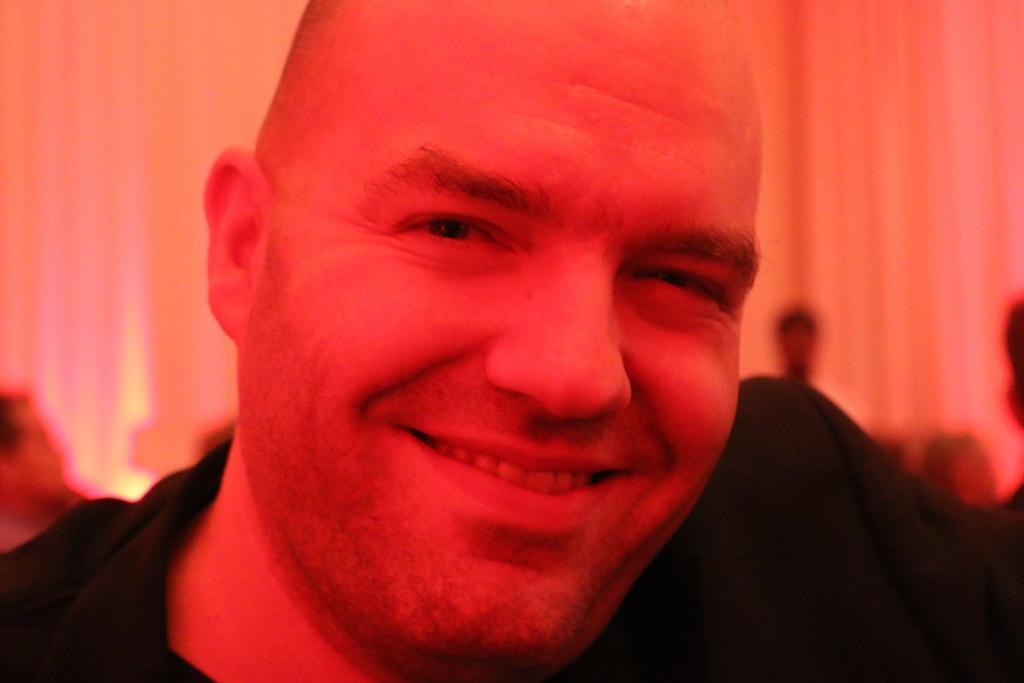How would you summarize this image in a sentence or two? In the picture we can see a man with a black shirt and the bending is heading towards the right and smiling and in his face we can see the red color light focus and behind him we can see some people are sitting and in the background we can see a curtain. 